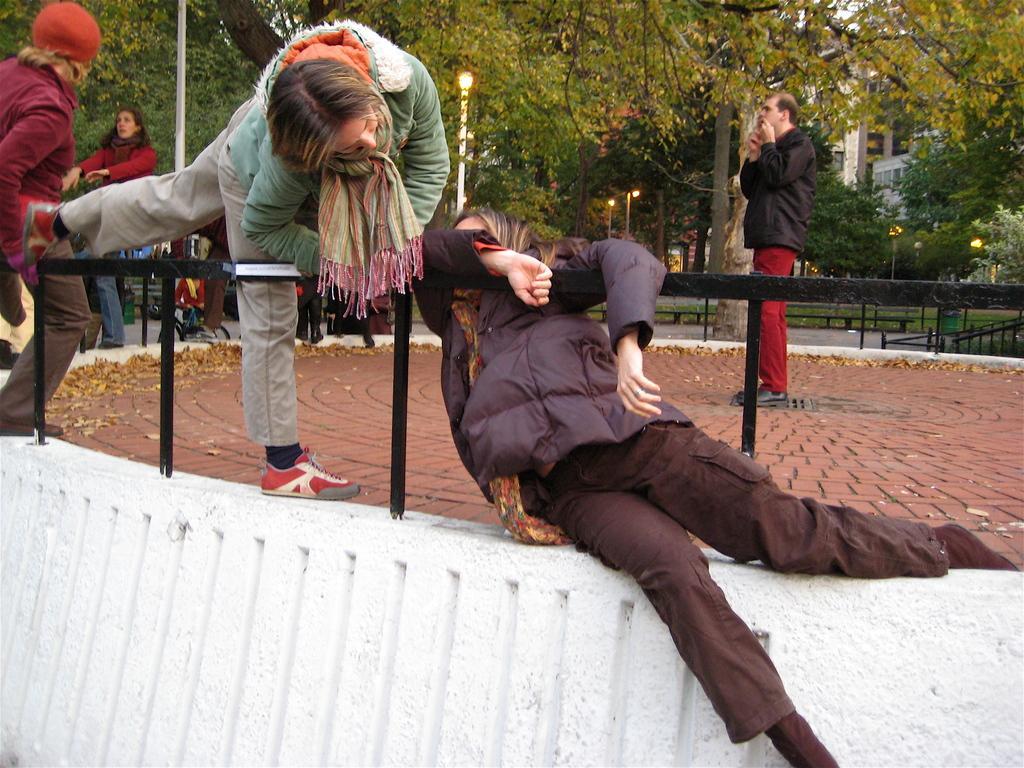Describe this image in one or two sentences. On the left side, there are two persons holding a fence. And they are on the white wall. In the background, there are other persons, there are trees and there is a building. 